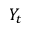Convert formula to latex. <formula><loc_0><loc_0><loc_500><loc_500>Y _ { t }</formula> 